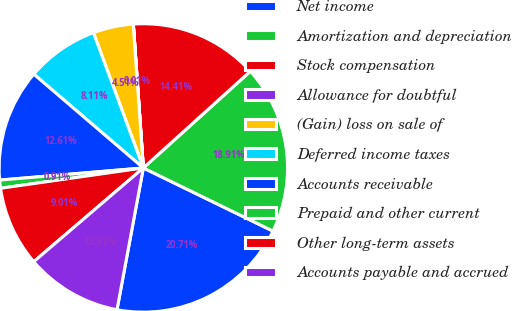<chart> <loc_0><loc_0><loc_500><loc_500><pie_chart><fcel>Net income<fcel>Amortization and depreciation<fcel>Stock compensation<fcel>Allowance for doubtful<fcel>(Gain) loss on sale of<fcel>Deferred income taxes<fcel>Accounts receivable<fcel>Prepaid and other current<fcel>Other long-term assets<fcel>Accounts payable and accrued<nl><fcel>20.71%<fcel>18.91%<fcel>14.41%<fcel>0.01%<fcel>4.51%<fcel>8.11%<fcel>12.61%<fcel>0.91%<fcel>9.01%<fcel>10.81%<nl></chart> 